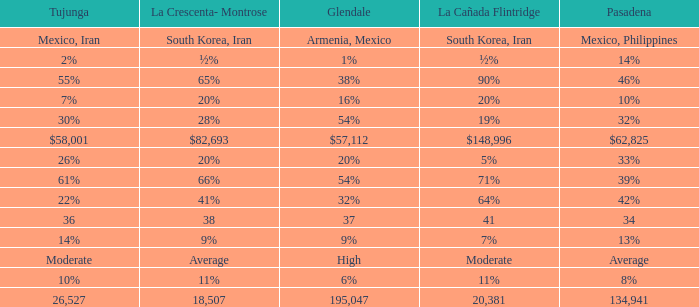When Tujunga is moderate, what is La Crescenta-Montrose? Average. 